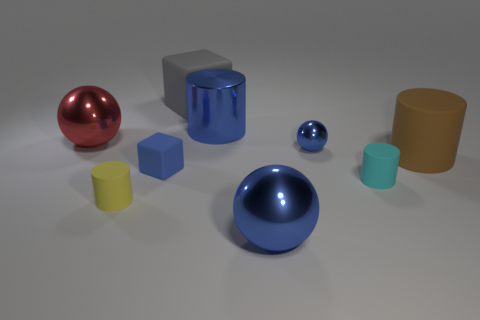Subtract 1 cylinders. How many cylinders are left? 3 Subtract all purple blocks. Subtract all cyan cylinders. How many blocks are left? 2 Add 1 large cylinders. How many objects exist? 10 Subtract all cubes. How many objects are left? 7 Add 7 blue shiny spheres. How many blue shiny spheres exist? 9 Subtract 0 cyan blocks. How many objects are left? 9 Subtract all cubes. Subtract all large cylinders. How many objects are left? 5 Add 9 small yellow matte things. How many small yellow matte things are left? 10 